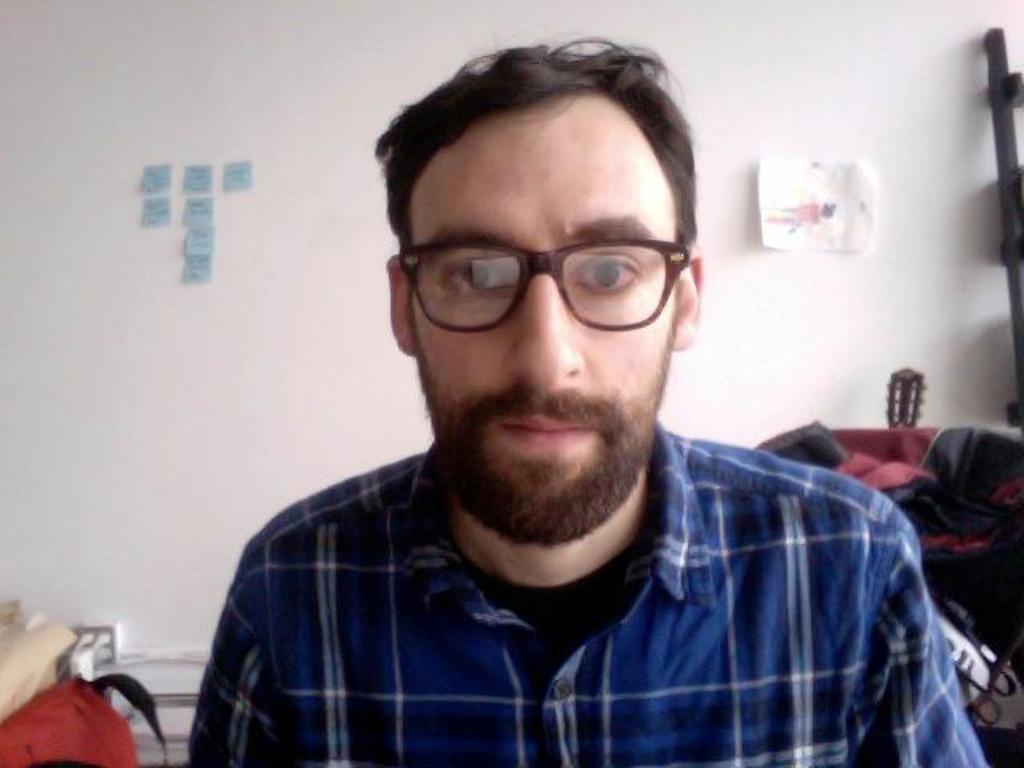In one or two sentences, can you explain what this image depicts? In this image, I can see the man with a shirt and spectacle. I can see the sticky notes and a paper attached to the wall. I can see few objects in the background. 